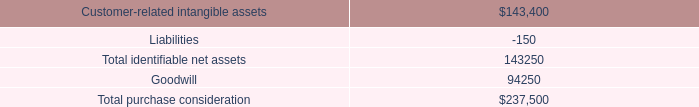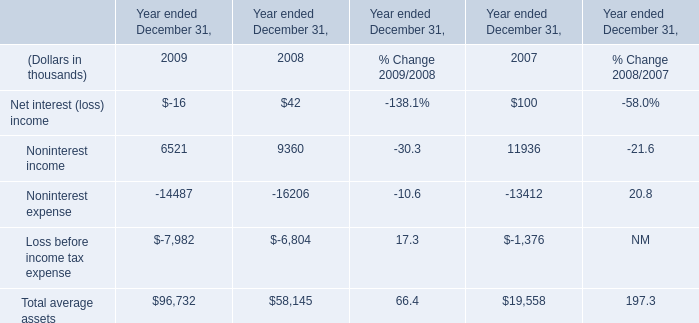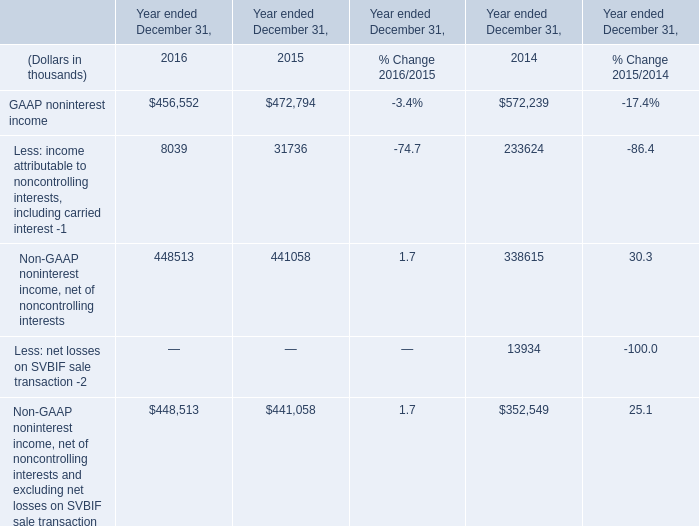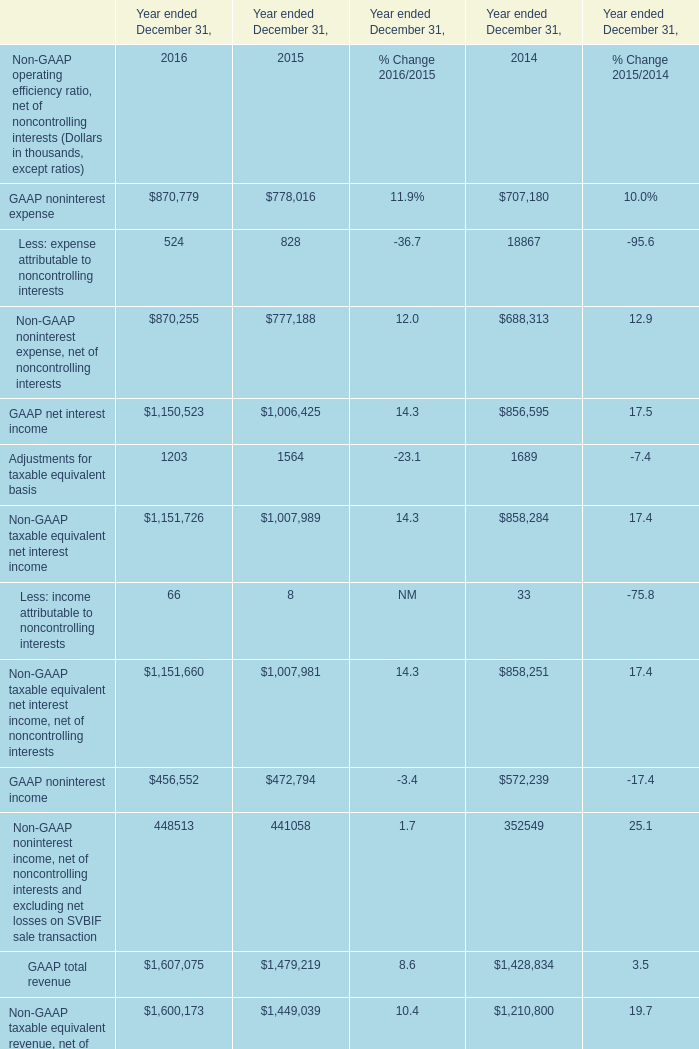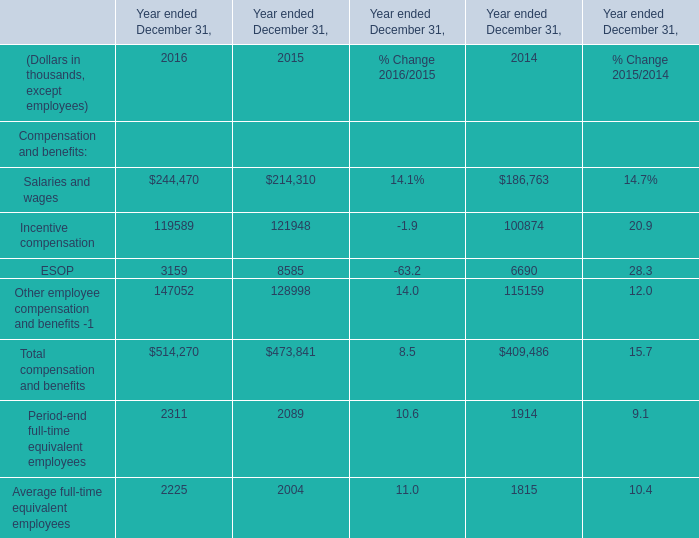What is the total amount of ESOP of Year ended December 31, 2014, and GAAP noninterest income of Year ended December 31, 2015 ? 
Computations: (6690.0 + 472794.0)
Answer: 479484.0. 